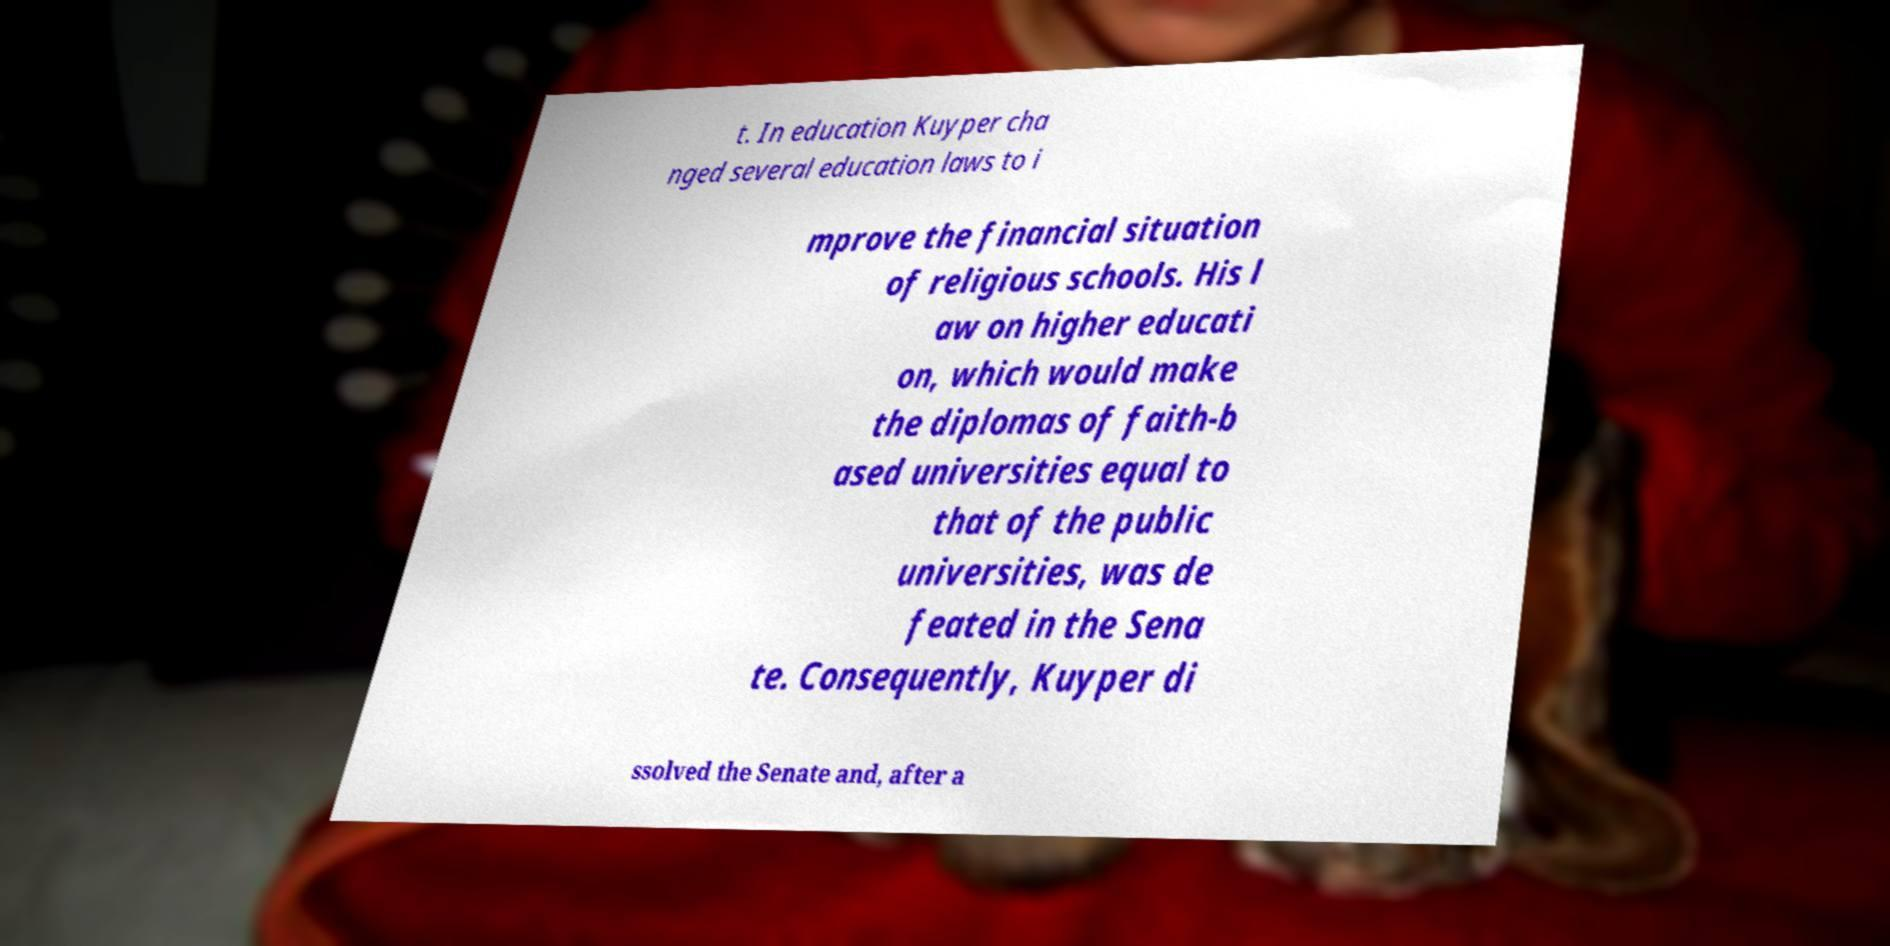Please read and relay the text visible in this image. What does it say? t. In education Kuyper cha nged several education laws to i mprove the financial situation of religious schools. His l aw on higher educati on, which would make the diplomas of faith-b ased universities equal to that of the public universities, was de feated in the Sena te. Consequently, Kuyper di ssolved the Senate and, after a 